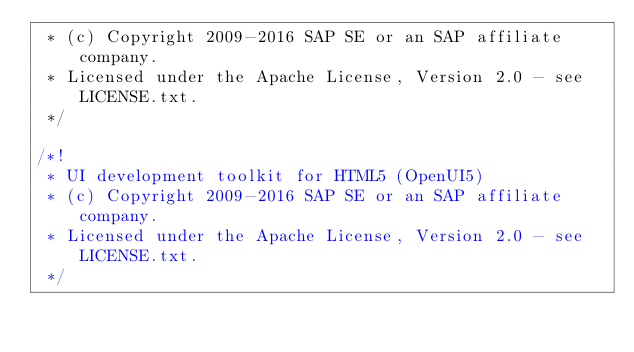Convert code to text. <code><loc_0><loc_0><loc_500><loc_500><_CSS_> * (c) Copyright 2009-2016 SAP SE or an SAP affiliate company.
 * Licensed under the Apache License, Version 2.0 - see LICENSE.txt.
 */
 
/*!
 * UI development toolkit for HTML5 (OpenUI5)
 * (c) Copyright 2009-2016 SAP SE or an SAP affiliate company.
 * Licensed under the Apache License, Version 2.0 - see LICENSE.txt.
 */</code> 